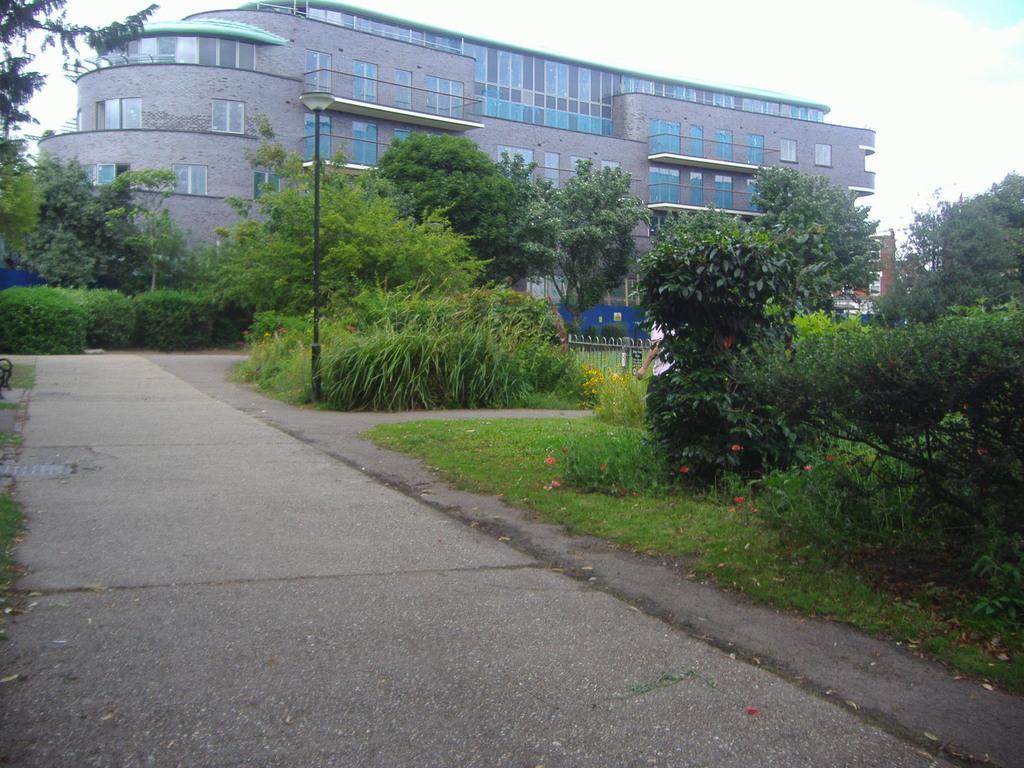Please provide a concise description of this image. In this image, we can see some trees and plants. There is a pole beside the road. There is a building at the top of the image. 